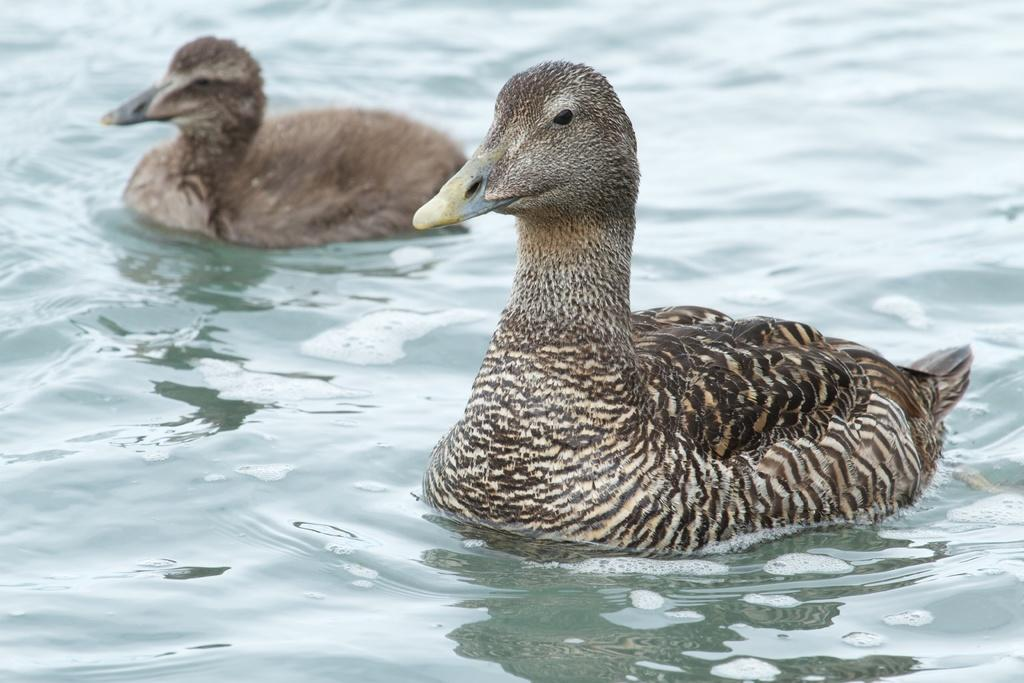How many birds are present in the image? There are two birds in the image. What colors can be seen on the birds? The birds are brown, cream, yellow, and black in color. Where are the birds located in the image? The birds are on the surface of the water. What type of sock is hanging from the wire in the image? There is no sock or wire present in the image; it features two birds on the surface of the water. 